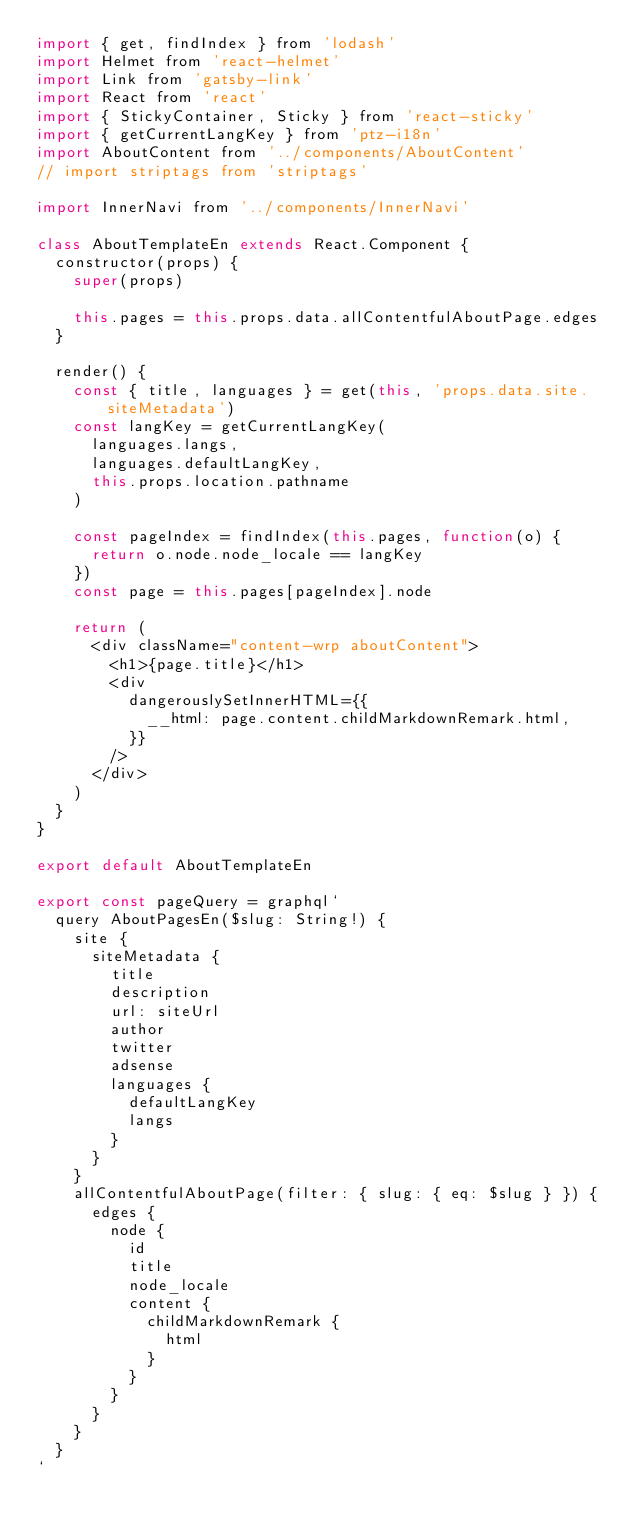<code> <loc_0><loc_0><loc_500><loc_500><_JavaScript_>import { get, findIndex } from 'lodash'
import Helmet from 'react-helmet'
import Link from 'gatsby-link'
import React from 'react'
import { StickyContainer, Sticky } from 'react-sticky'
import { getCurrentLangKey } from 'ptz-i18n'
import AboutContent from '../components/AboutContent'
// import striptags from 'striptags'

import InnerNavi from '../components/InnerNavi'

class AboutTemplateEn extends React.Component {
  constructor(props) {
    super(props)

    this.pages = this.props.data.allContentfulAboutPage.edges
  }

  render() {
    const { title, languages } = get(this, 'props.data.site.siteMetadata')
    const langKey = getCurrentLangKey(
      languages.langs,
      languages.defaultLangKey,
      this.props.location.pathname
    )

    const pageIndex = findIndex(this.pages, function(o) {
      return o.node.node_locale == langKey
    })
    const page = this.pages[pageIndex].node

    return (
      <div className="content-wrp aboutContent">
        <h1>{page.title}</h1>
        <div
          dangerouslySetInnerHTML={{
            __html: page.content.childMarkdownRemark.html,
          }}
        />
      </div>
    )
  }
}

export default AboutTemplateEn

export const pageQuery = graphql`
  query AboutPagesEn($slug: String!) {
    site {
      siteMetadata {
        title
        description
        url: siteUrl
        author
        twitter
        adsense
        languages {
          defaultLangKey
          langs
        }
      }
    }
    allContentfulAboutPage(filter: { slug: { eq: $slug } }) {
      edges {
        node {
          id
          title
          node_locale
          content {
            childMarkdownRemark {
              html
            }
          }
        }
      }
    }
  }
`
</code> 